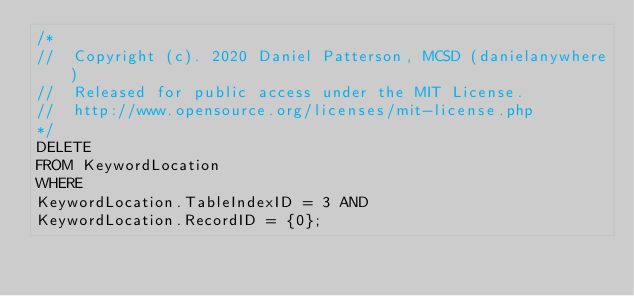<code> <loc_0><loc_0><loc_500><loc_500><_SQL_>/*
//	Copyright (c). 2020 Daniel Patterson, MCSD (danielanywhere)
//	Released for public access under the MIT License.
//	http://www.opensource.org/licenses/mit-license.php
*/
DELETE
FROM KeywordLocation
WHERE
KeywordLocation.TableIndexID = 3 AND
KeywordLocation.RecordID = {0};
</code> 